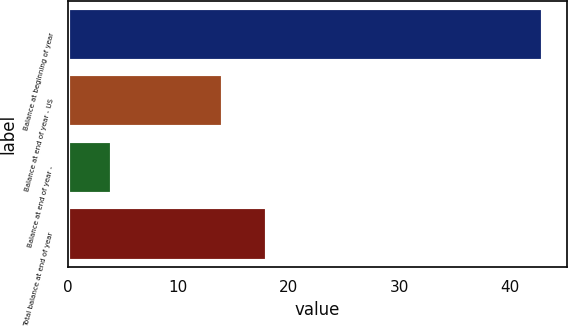<chart> <loc_0><loc_0><loc_500><loc_500><bar_chart><fcel>Balance at beginning of year<fcel>Balance at end of year - US<fcel>Balance at end of year -<fcel>Total balance at end of year<nl><fcel>43<fcel>14<fcel>4<fcel>18<nl></chart> 